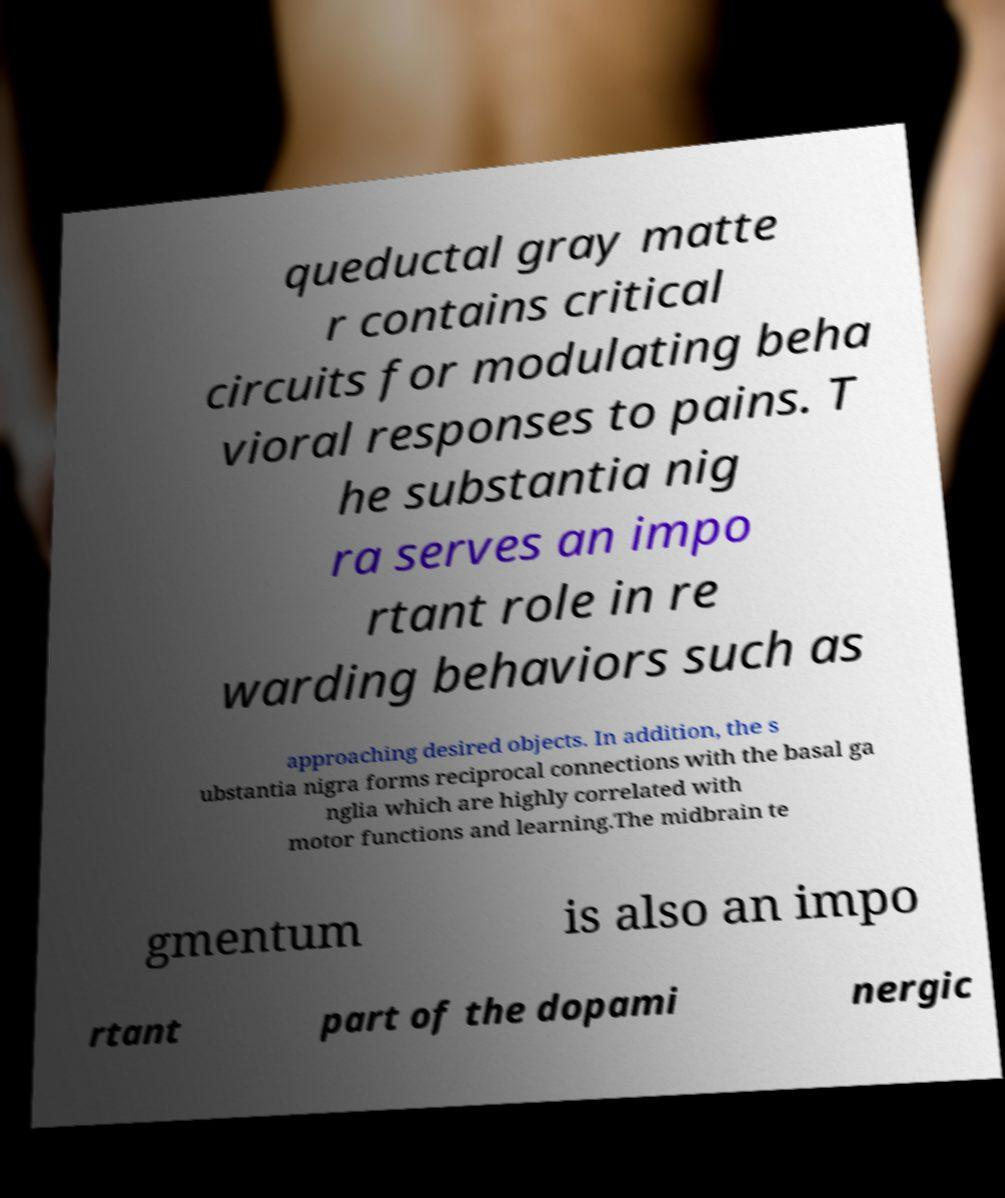Please read and relay the text visible in this image. What does it say? queductal gray matte r contains critical circuits for modulating beha vioral responses to pains. T he substantia nig ra serves an impo rtant role in re warding behaviors such as approaching desired objects. In addition, the s ubstantia nigra forms reciprocal connections with the basal ga nglia which are highly correlated with motor functions and learning.The midbrain te gmentum is also an impo rtant part of the dopami nergic 